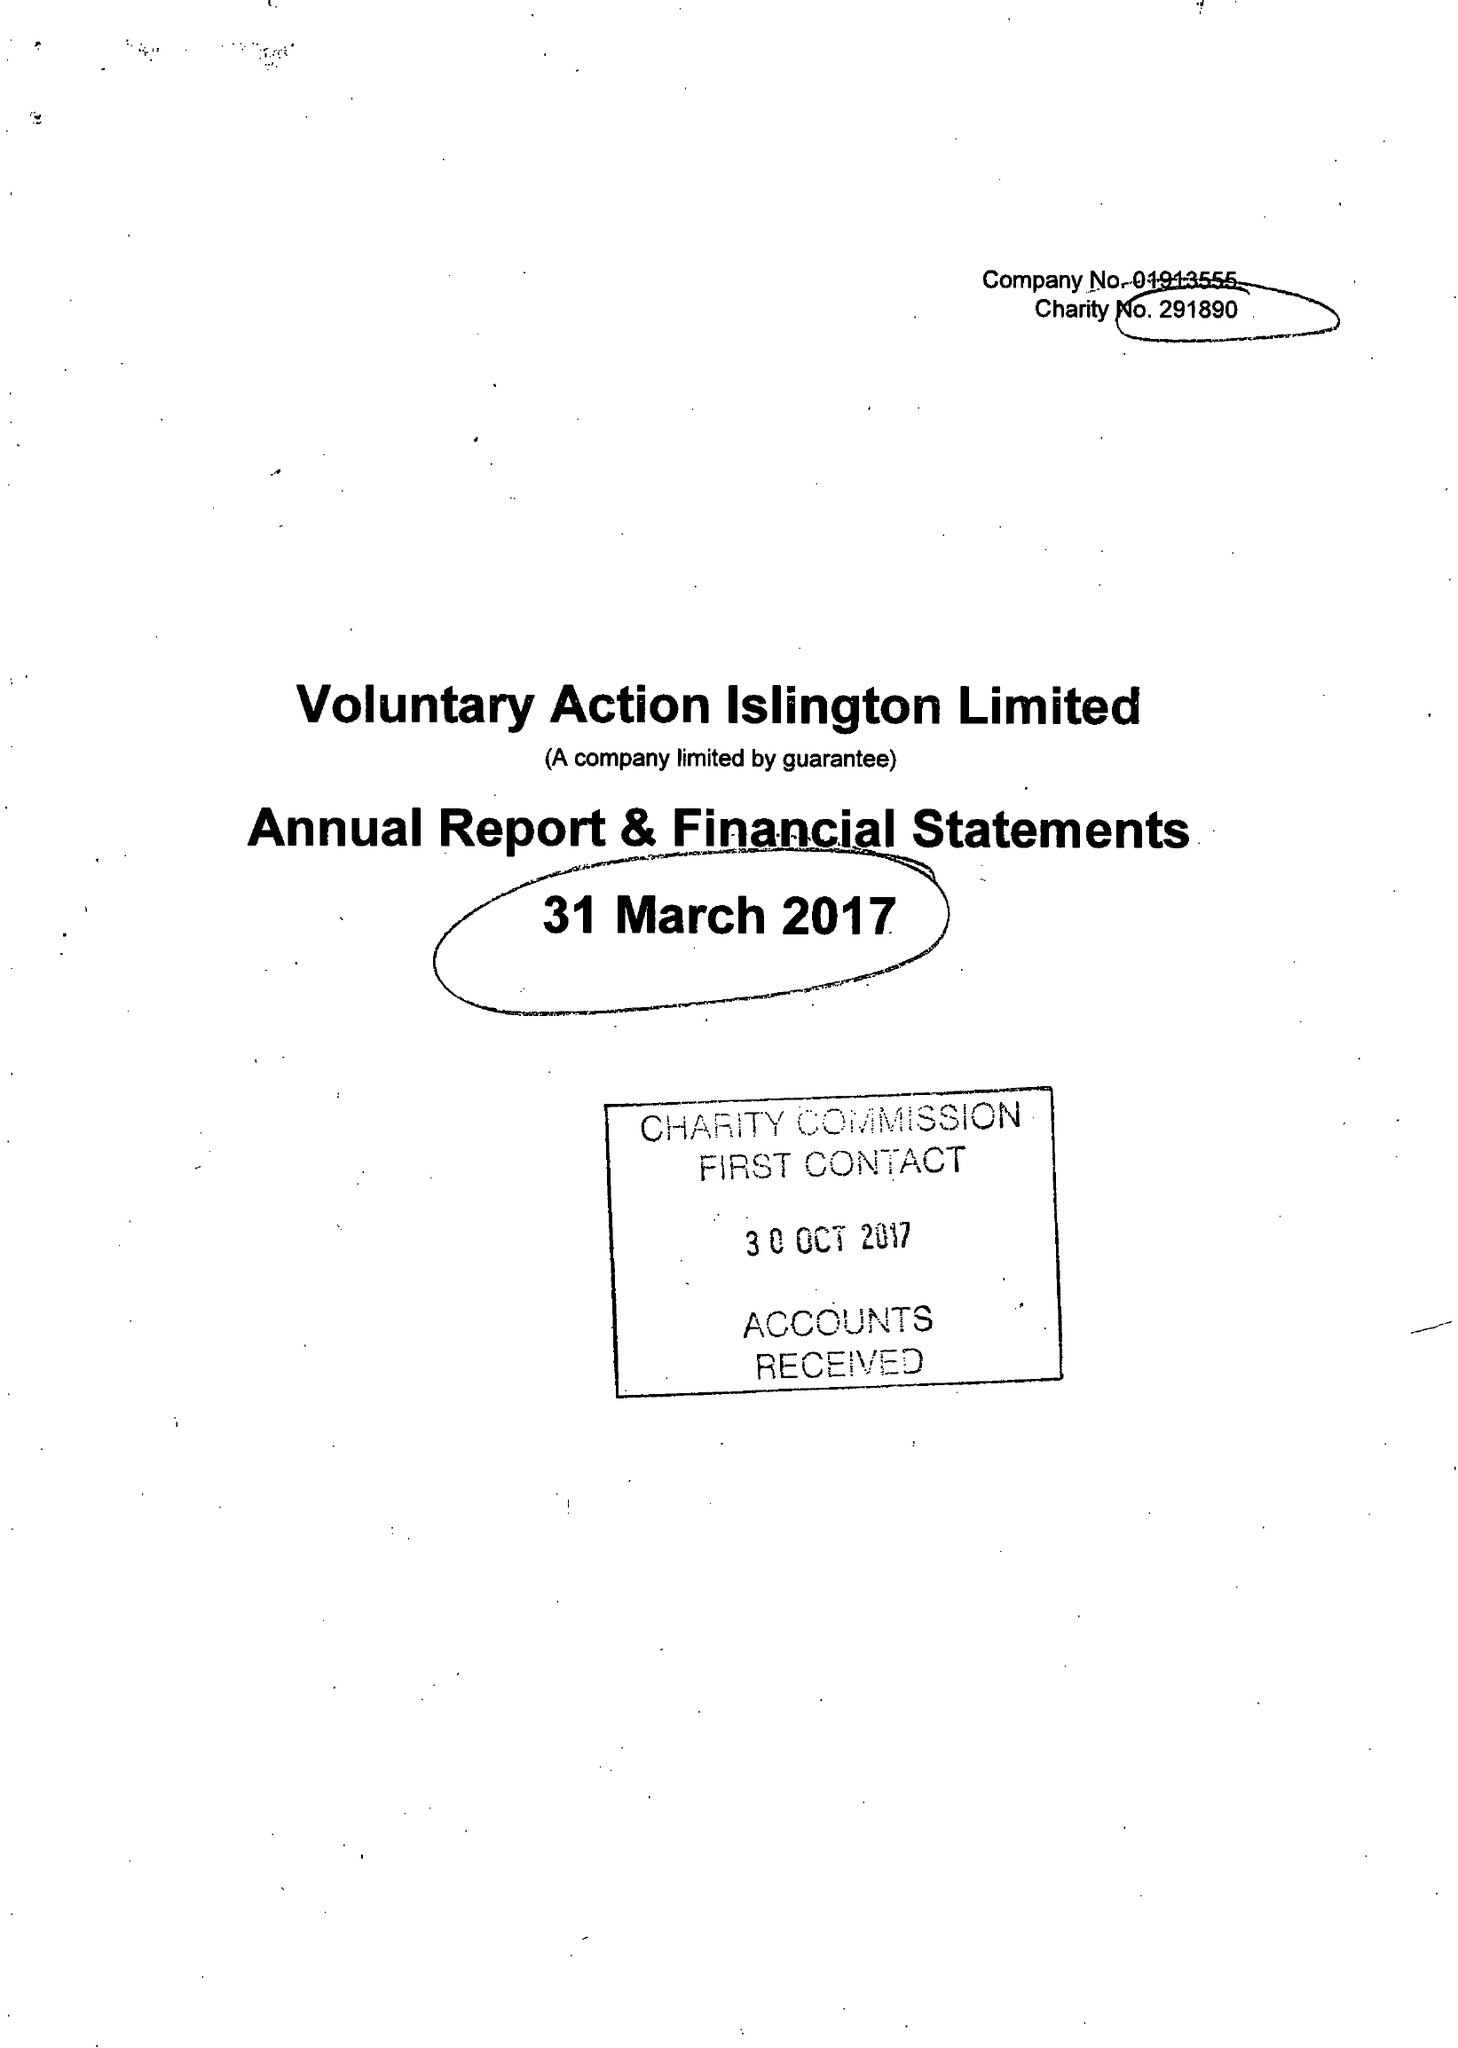What is the value for the address__post_town?
Answer the question using a single word or phrase. LONDON 